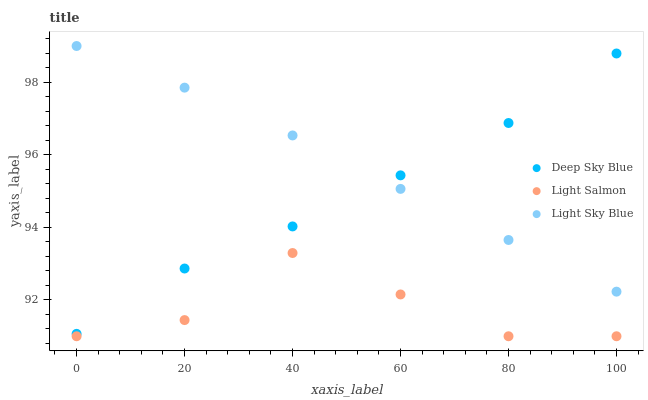Does Light Salmon have the minimum area under the curve?
Answer yes or no. Yes. Does Light Sky Blue have the maximum area under the curve?
Answer yes or no. Yes. Does Deep Sky Blue have the minimum area under the curve?
Answer yes or no. No. Does Deep Sky Blue have the maximum area under the curve?
Answer yes or no. No. Is Light Sky Blue the smoothest?
Answer yes or no. Yes. Is Light Salmon the roughest?
Answer yes or no. Yes. Is Deep Sky Blue the smoothest?
Answer yes or no. No. Is Deep Sky Blue the roughest?
Answer yes or no. No. Does Light Salmon have the lowest value?
Answer yes or no. Yes. Does Deep Sky Blue have the lowest value?
Answer yes or no. No. Does Light Sky Blue have the highest value?
Answer yes or no. Yes. Does Deep Sky Blue have the highest value?
Answer yes or no. No. Is Light Salmon less than Deep Sky Blue?
Answer yes or no. Yes. Is Deep Sky Blue greater than Light Salmon?
Answer yes or no. Yes. Does Light Sky Blue intersect Deep Sky Blue?
Answer yes or no. Yes. Is Light Sky Blue less than Deep Sky Blue?
Answer yes or no. No. Is Light Sky Blue greater than Deep Sky Blue?
Answer yes or no. No. Does Light Salmon intersect Deep Sky Blue?
Answer yes or no. No. 